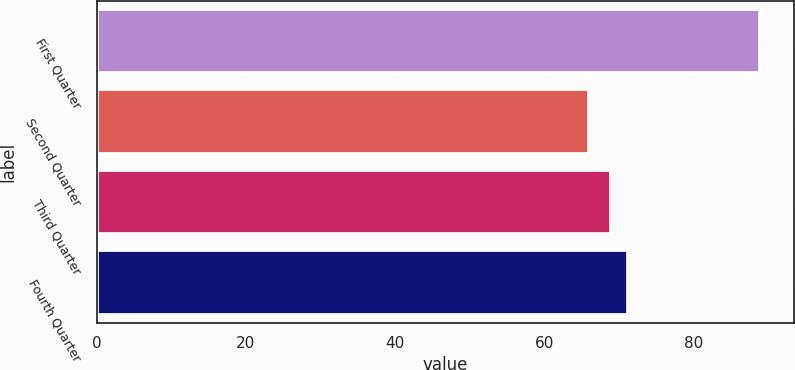Convert chart. <chart><loc_0><loc_0><loc_500><loc_500><bar_chart><fcel>First Quarter<fcel>Second Quarter<fcel>Third Quarter<fcel>Fourth Quarter<nl><fcel>89<fcel>66<fcel>69<fcel>71.3<nl></chart> 